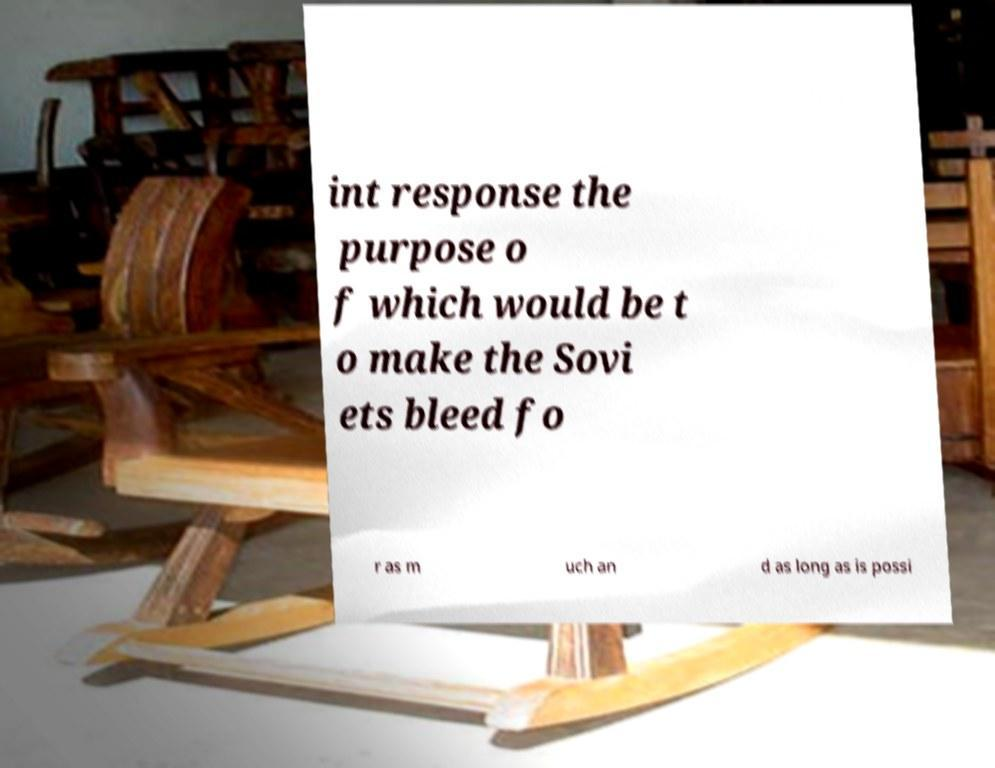I need the written content from this picture converted into text. Can you do that? int response the purpose o f which would be t o make the Sovi ets bleed fo r as m uch an d as long as is possi 